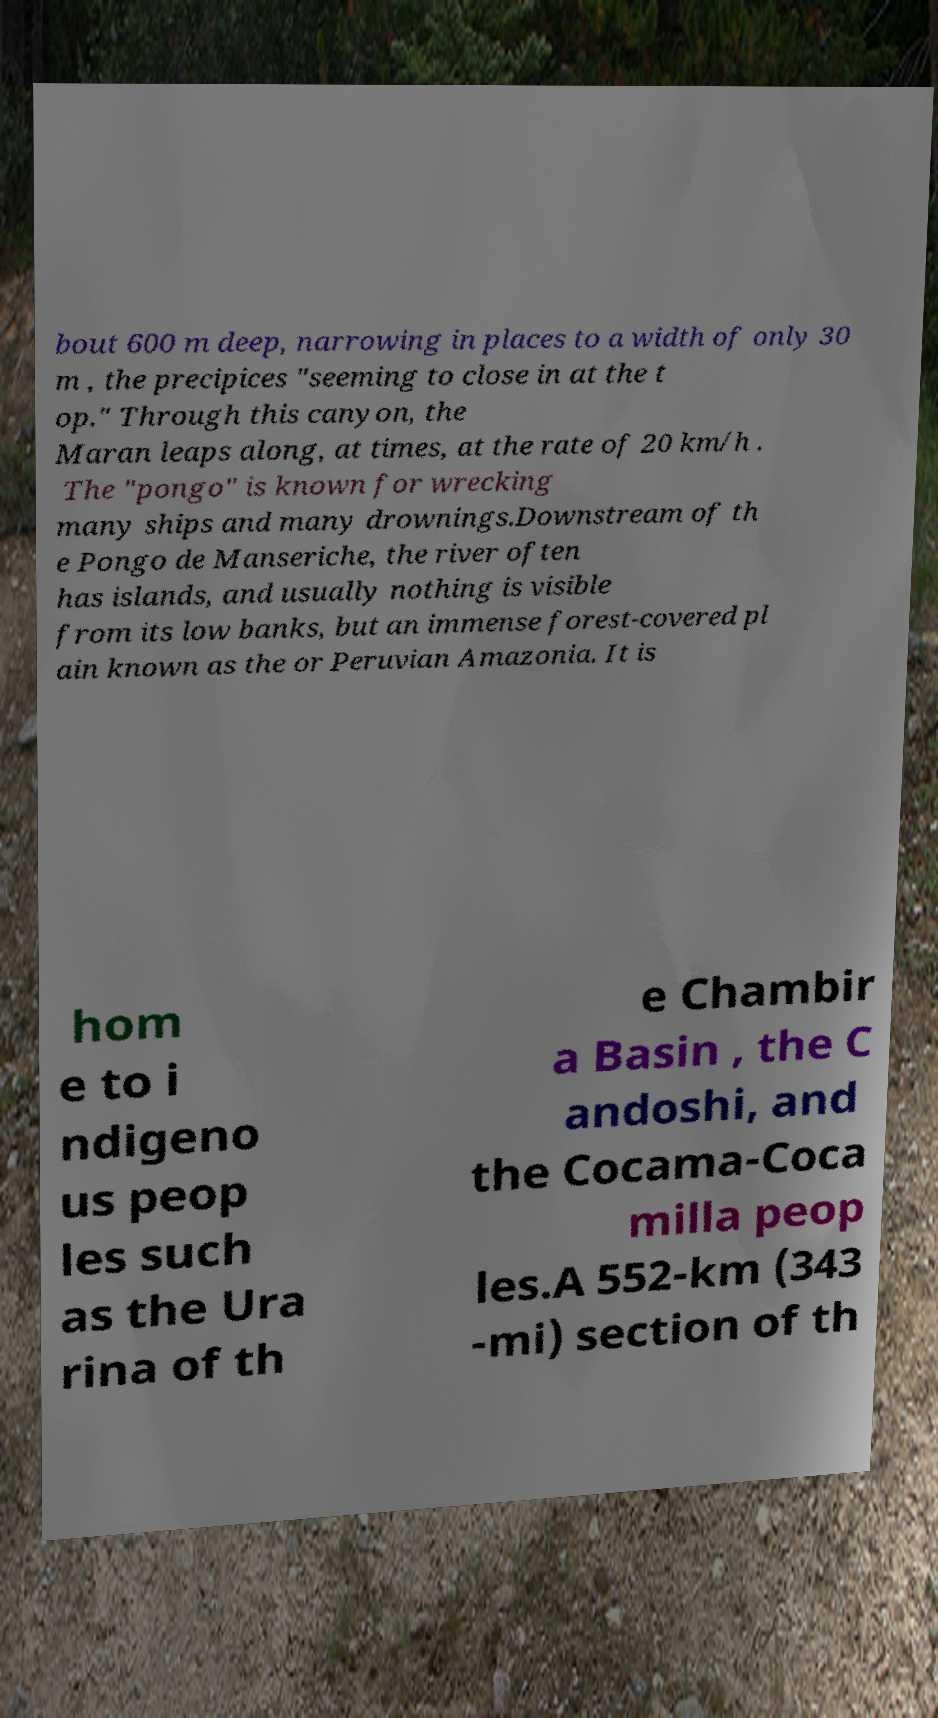I need the written content from this picture converted into text. Can you do that? bout 600 m deep, narrowing in places to a width of only 30 m , the precipices "seeming to close in at the t op." Through this canyon, the Maran leaps along, at times, at the rate of 20 km/h . The "pongo" is known for wrecking many ships and many drownings.Downstream of th e Pongo de Manseriche, the river often has islands, and usually nothing is visible from its low banks, but an immense forest-covered pl ain known as the or Peruvian Amazonia. It is hom e to i ndigeno us peop les such as the Ura rina of th e Chambir a Basin , the C andoshi, and the Cocama-Coca milla peop les.A 552-km (343 -mi) section of th 